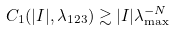<formula> <loc_0><loc_0><loc_500><loc_500>C _ { 1 } ( | I | , \lambda _ { 1 2 3 } ) \gtrsim | I | \lambda _ { \max } ^ { - N }</formula> 